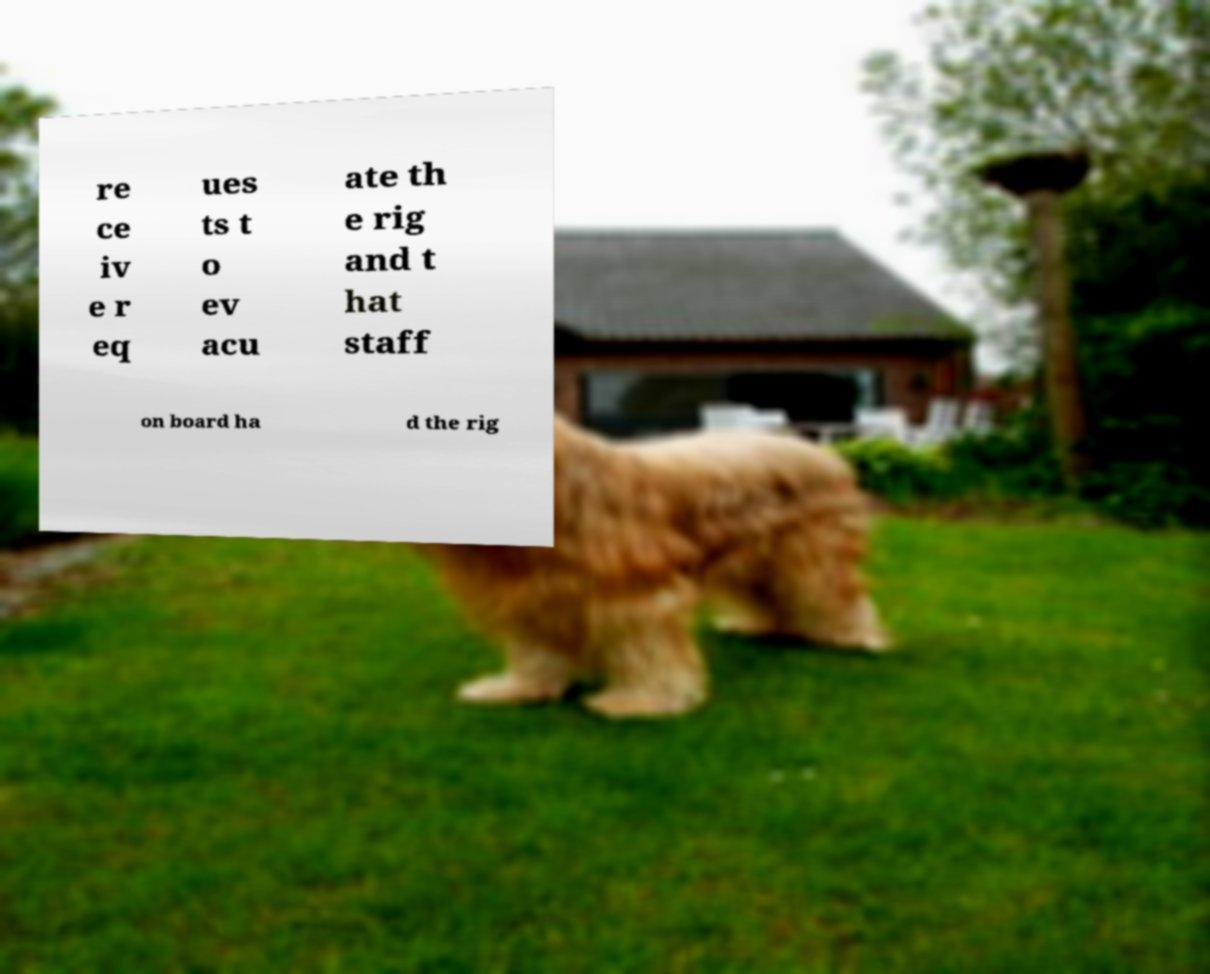Can you read and provide the text displayed in the image?This photo seems to have some interesting text. Can you extract and type it out for me? re ce iv e r eq ues ts t o ev acu ate th e rig and t hat staff on board ha d the rig 